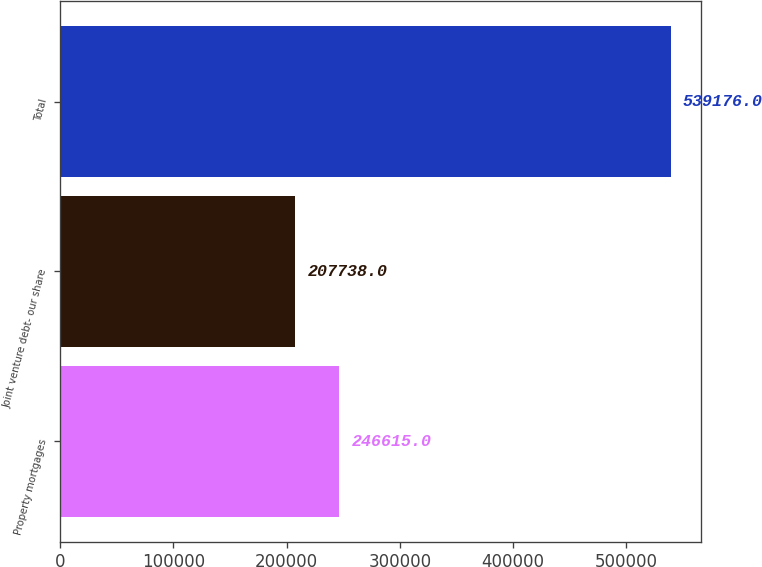Convert chart to OTSL. <chart><loc_0><loc_0><loc_500><loc_500><bar_chart><fcel>Property mortgages<fcel>Joint venture debt- our share<fcel>Total<nl><fcel>246615<fcel>207738<fcel>539176<nl></chart> 